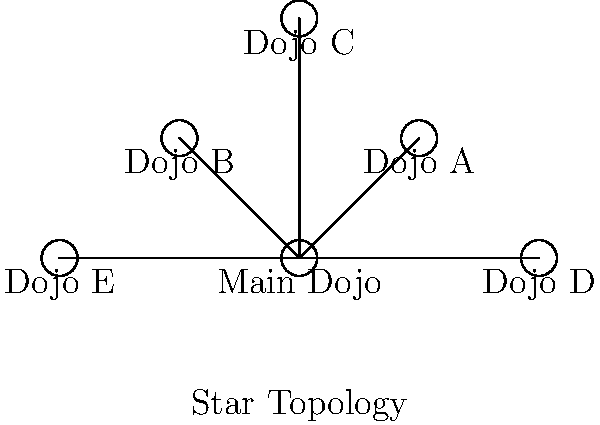As your martial arts school expands to multiple locations in Clermont and surrounding areas, you need to set up a network to connect all dojos. Based on the diagram, which network topology is most suitable for connecting the main dojo with its branches, ensuring centralized control and easy management? To determine the most suitable network topology for connecting multiple dojos, let's analyze the diagram and consider the requirements:

1. The diagram shows a central node (Main Dojo) connected directly to all other nodes (Dojo A, B, C, D, and E).
2. Each branch dojo has a direct connection to the main dojo.
3. There are no connections between the branch dojos.
4. This configuration allows for centralized control from the main dojo.
5. It facilitates easy management as all communication goes through the central node.
6. The topology shown in the diagram is known as a Star Topology.

In a Star Topology:
- The central node (Main Dojo) acts as a hub.
- All other nodes (branch dojos) are connected directly to the central node.
- Communication between branch dojos must pass through the central node.
- It provides excellent centralized control and management.
- Adding or removing branch dojos is relatively easy without disrupting the entire network.

Given the requirements for centralized control and easy management in a martial arts school setting, the Star Topology is the most suitable choice for connecting the main dojo with its branches.
Answer: Star Topology 